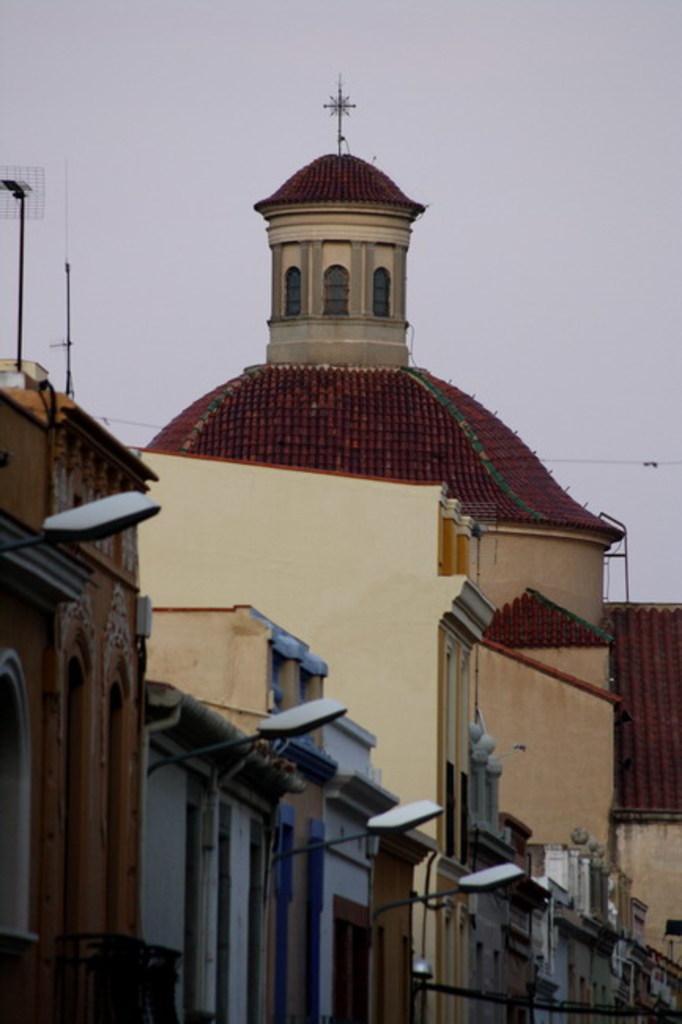How would you summarize this image in a sentence or two? In this image there is the sky truncated towards the top of the image, there are buildings truncated towards the bottom of the image, there are buildings truncated towards the right of the image, there are buildings truncated towards the left of the image, there are street lights, there is a wire truncated towards the right of the image, there are poles, there is an object truncated towards the left of the image. 